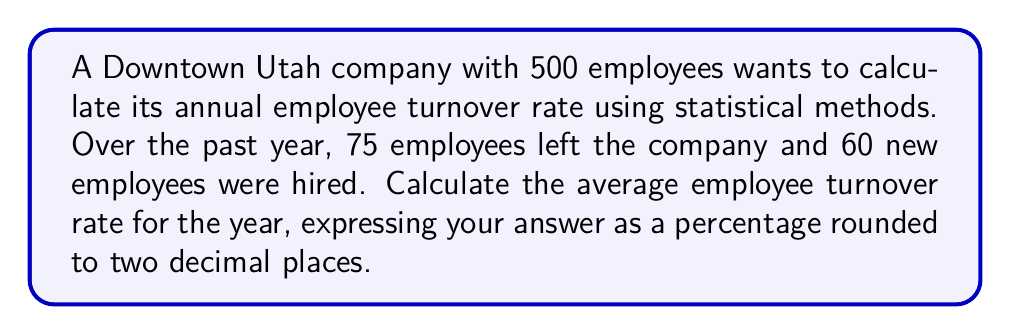Solve this math problem. To calculate the employee turnover rate, we'll use the following steps:

1. Define the formula for employee turnover rate:

   $$ \text{Turnover Rate} = \frac{\text{Number of Separations}}{\text{Average Number of Employees}} \times 100\% $$

2. Calculate the average number of employees:
   
   $$ \text{Average Employees} = \frac{\text{Beginning Employees} + \text{Ending Employees}}{2} $$

   Beginning Employees = 500
   Ending Employees = 500 - 75 + 60 = 485

   $$ \text{Average Employees} = \frac{500 + 485}{2} = 492.5 $$

3. Apply the turnover rate formula:

   $$ \text{Turnover Rate} = \frac{75}{492.5} \times 100\% $$

4. Calculate the result:

   $$ \text{Turnover Rate} = 0.1522448979591837 \times 100\% = 15.22448979591837\% $$

5. Round to two decimal places:

   $$ \text{Turnover Rate} \approx 15.22\% $$
Answer: 15.22% 